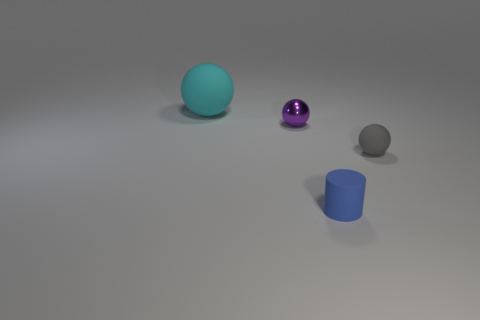If you were to create a story involving these objects, what role would each play? In a story, the cyan sphere could be a mysterious planet, the purple sphere a magical orb of power, the gray sphere might be an ancient moon with secrets buried beneath its surface, and the blue cylinder could serve as a portal or a container for an unknown element essential to the plot's progression. 